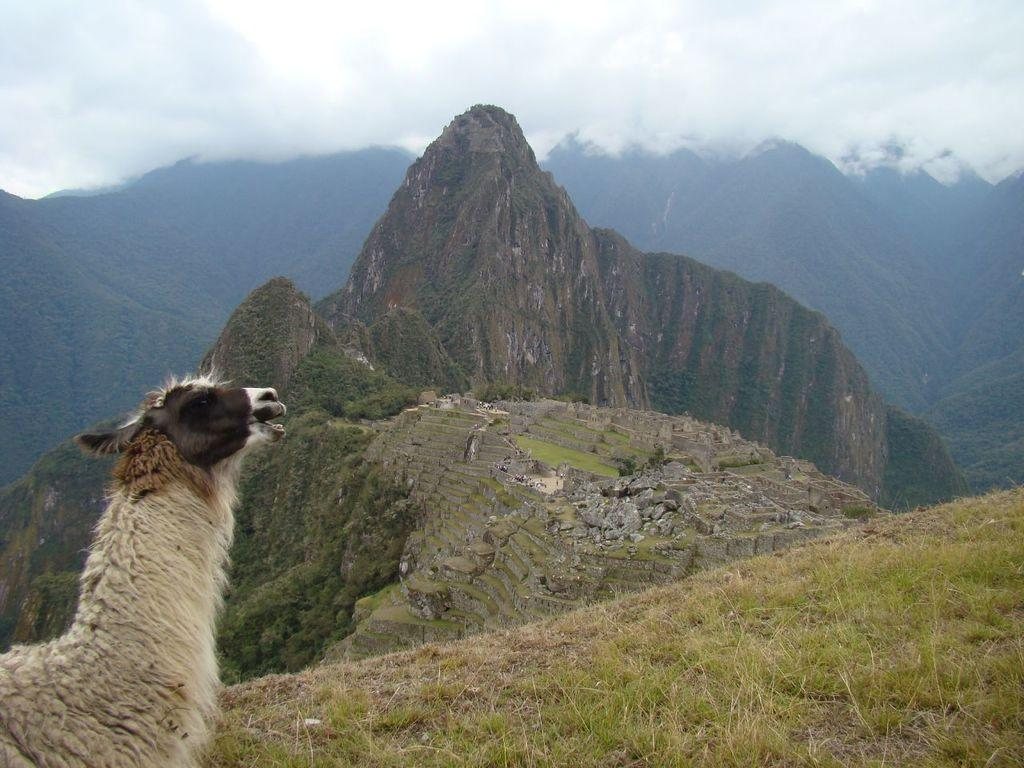What animal is located on the left side of the image? There is a goat on the left side of the image. What type of vegetation is in the center of the image? There is grass in the center of the image. What geographical feature can be seen in the background of the image? There are mountains in the background of the image. What is visible at the top of the image? The sky is visible at the top of the image. Can you tell me how many tomatoes are growing on the goat in the image? There are no tomatoes present in the image, and the goat is not a plant for growing tomatoes. Is the goat swimming in the grass in the image? The goat is not swimming in the grass; it is standing on the grass in the image. 